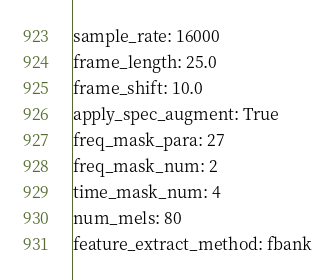<code> <loc_0><loc_0><loc_500><loc_500><_YAML_>sample_rate: 16000
frame_length: 25.0
frame_shift: 10.0
apply_spec_augment: True
freq_mask_para: 27
freq_mask_num: 2
time_mask_num: 4
num_mels: 80
feature_extract_method: fbank</code> 